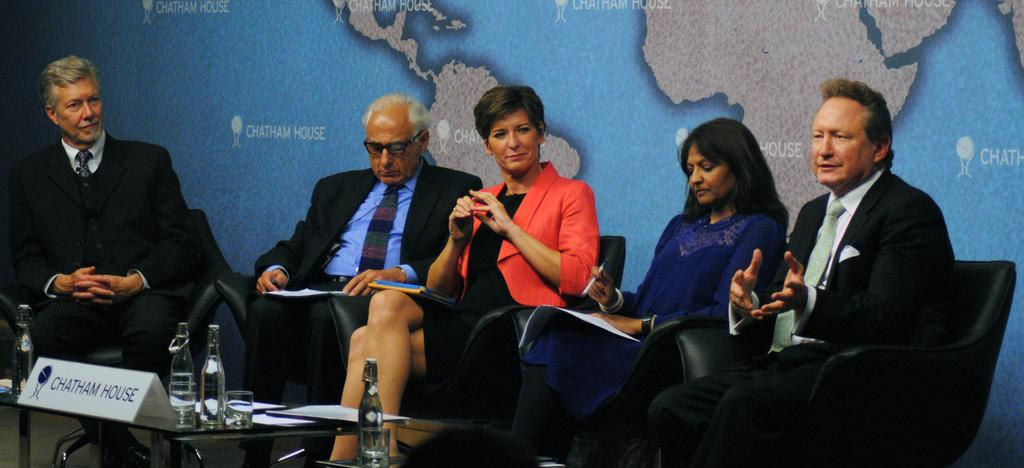What are the people in the image doing? The persons in the center of the image are sitting on chairs. Where is the table located in the image? The table is in the bottom left corner of the image. What items can be seen on the table? There are bottles and a board on the table. What can be seen in the background of the image? There is a map in the background of the image. What type of maid is serving the persons in the image? There is no maid present in the image. What is the air quality like in the image? The provided facts do not give any information about the air quality in the image. 